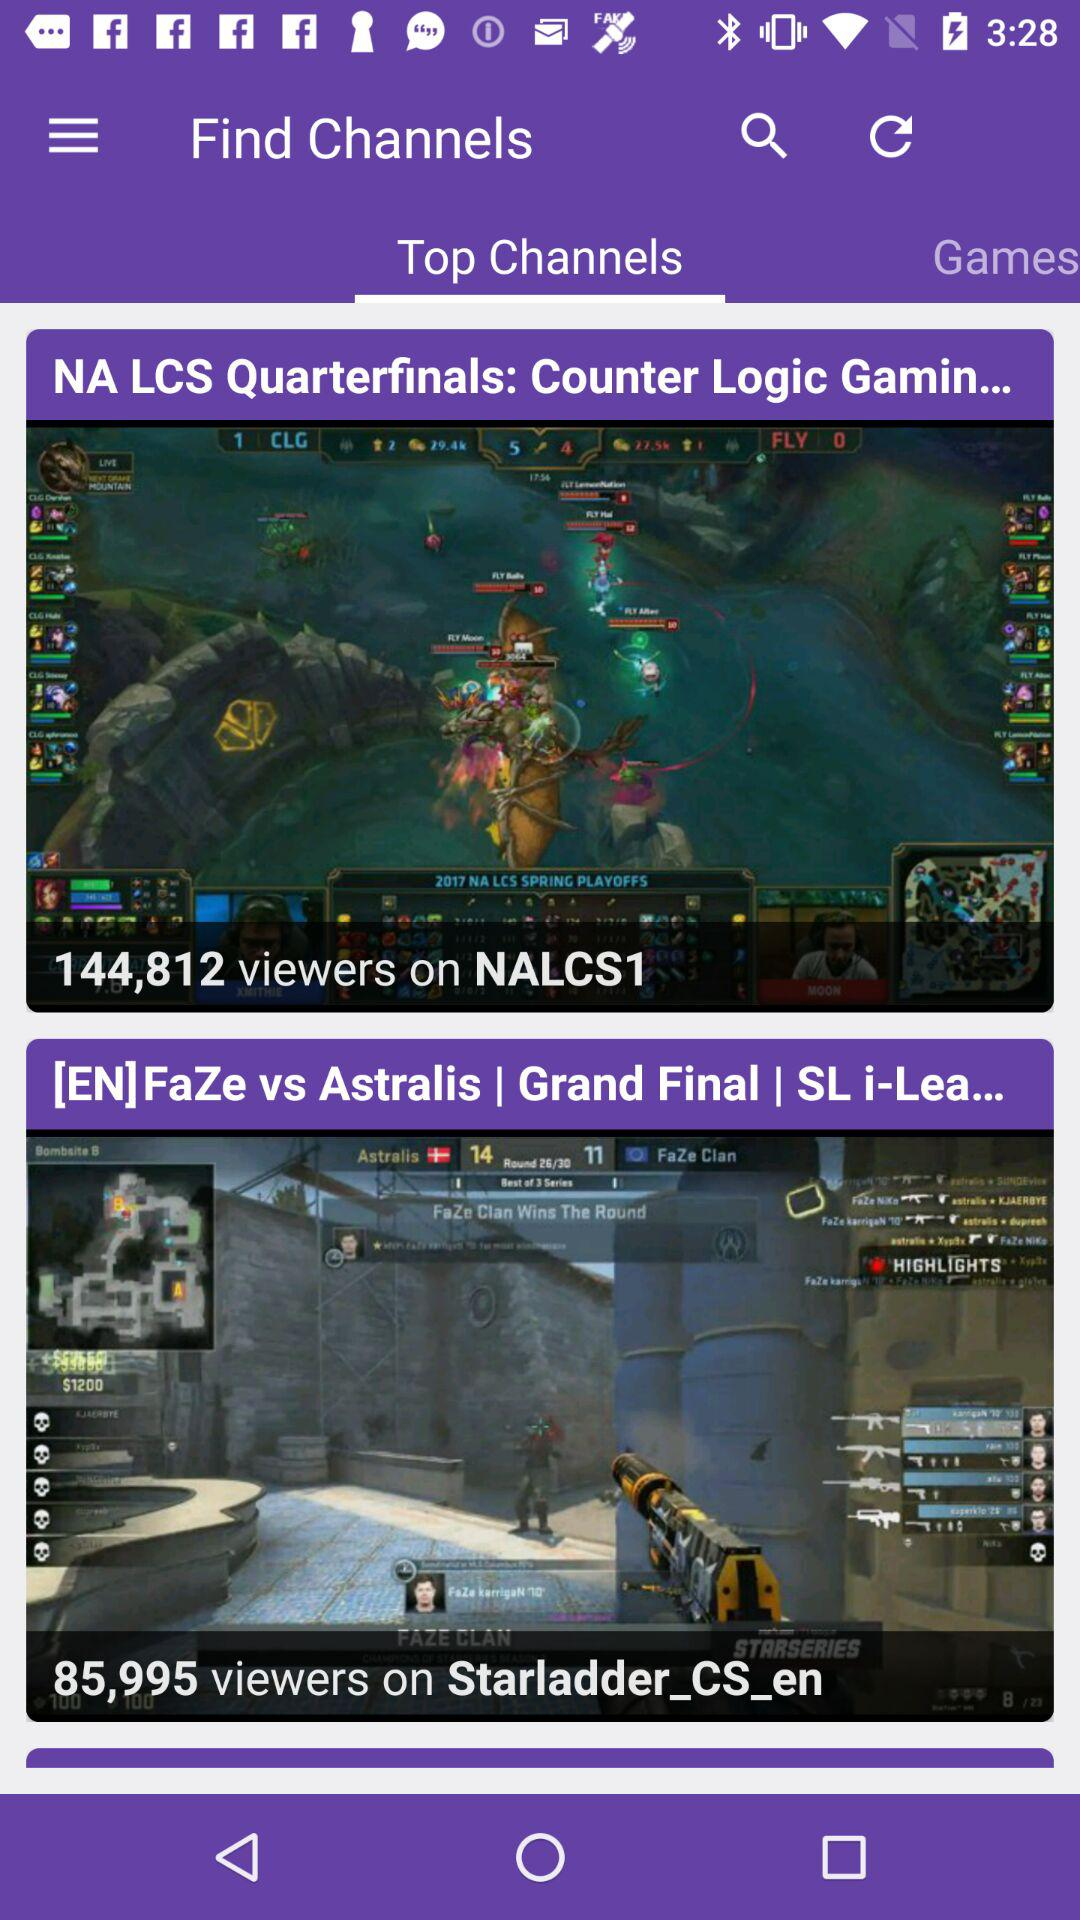How many more viewers does the NA LCS Quarterfinals have than the [EN]FaZe vs Astralis game?
Answer the question using a single word or phrase. 58817 